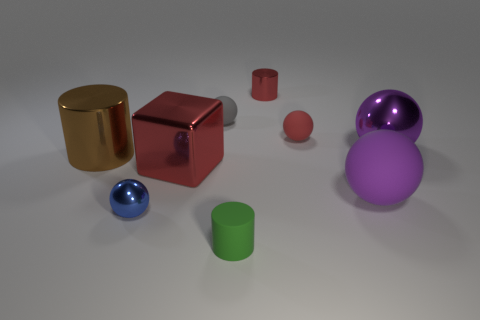Subtract all green cylinders. How many cylinders are left? 2 Subtract all yellow cylinders. How many purple balls are left? 2 Subtract 1 balls. How many balls are left? 4 Add 1 brown shiny things. How many objects exist? 10 Subtract all gray balls. How many balls are left? 4 Subtract all balls. How many objects are left? 4 Subtract all blue balls. Subtract all cyan blocks. How many balls are left? 4 Subtract 0 gray cylinders. How many objects are left? 9 Subtract all green objects. Subtract all large purple shiny balls. How many objects are left? 7 Add 5 green objects. How many green objects are left? 6 